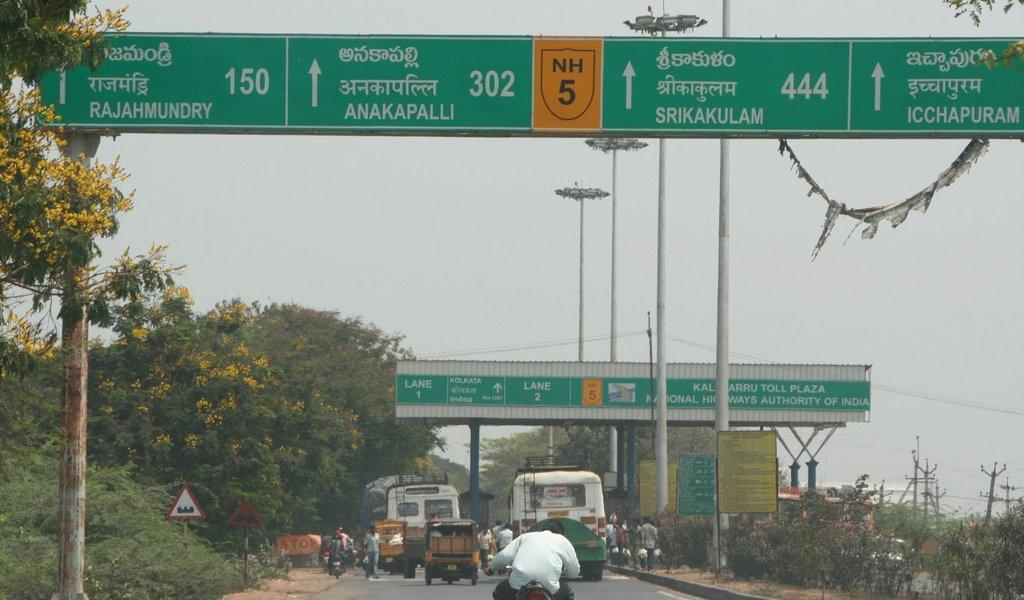<image>
Offer a succinct explanation of the picture presented. A green road sign above the road points to the way to Anakapalli 302. 